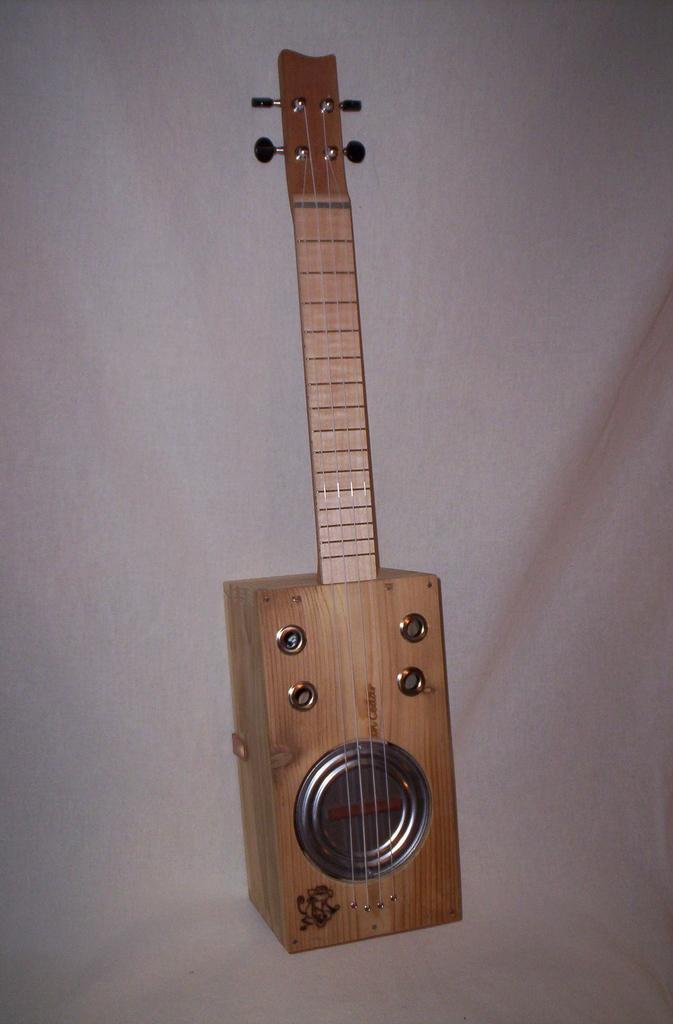Can you describe this image briefly? In this images we can see a wooden guitar which is lying on a bed. 